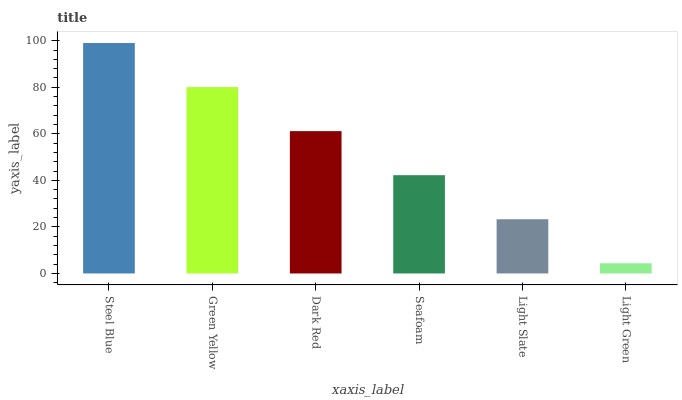Is Light Green the minimum?
Answer yes or no. Yes. Is Steel Blue the maximum?
Answer yes or no. Yes. Is Green Yellow the minimum?
Answer yes or no. No. Is Green Yellow the maximum?
Answer yes or no. No. Is Steel Blue greater than Green Yellow?
Answer yes or no. Yes. Is Green Yellow less than Steel Blue?
Answer yes or no. Yes. Is Green Yellow greater than Steel Blue?
Answer yes or no. No. Is Steel Blue less than Green Yellow?
Answer yes or no. No. Is Dark Red the high median?
Answer yes or no. Yes. Is Seafoam the low median?
Answer yes or no. Yes. Is Green Yellow the high median?
Answer yes or no. No. Is Dark Red the low median?
Answer yes or no. No. 